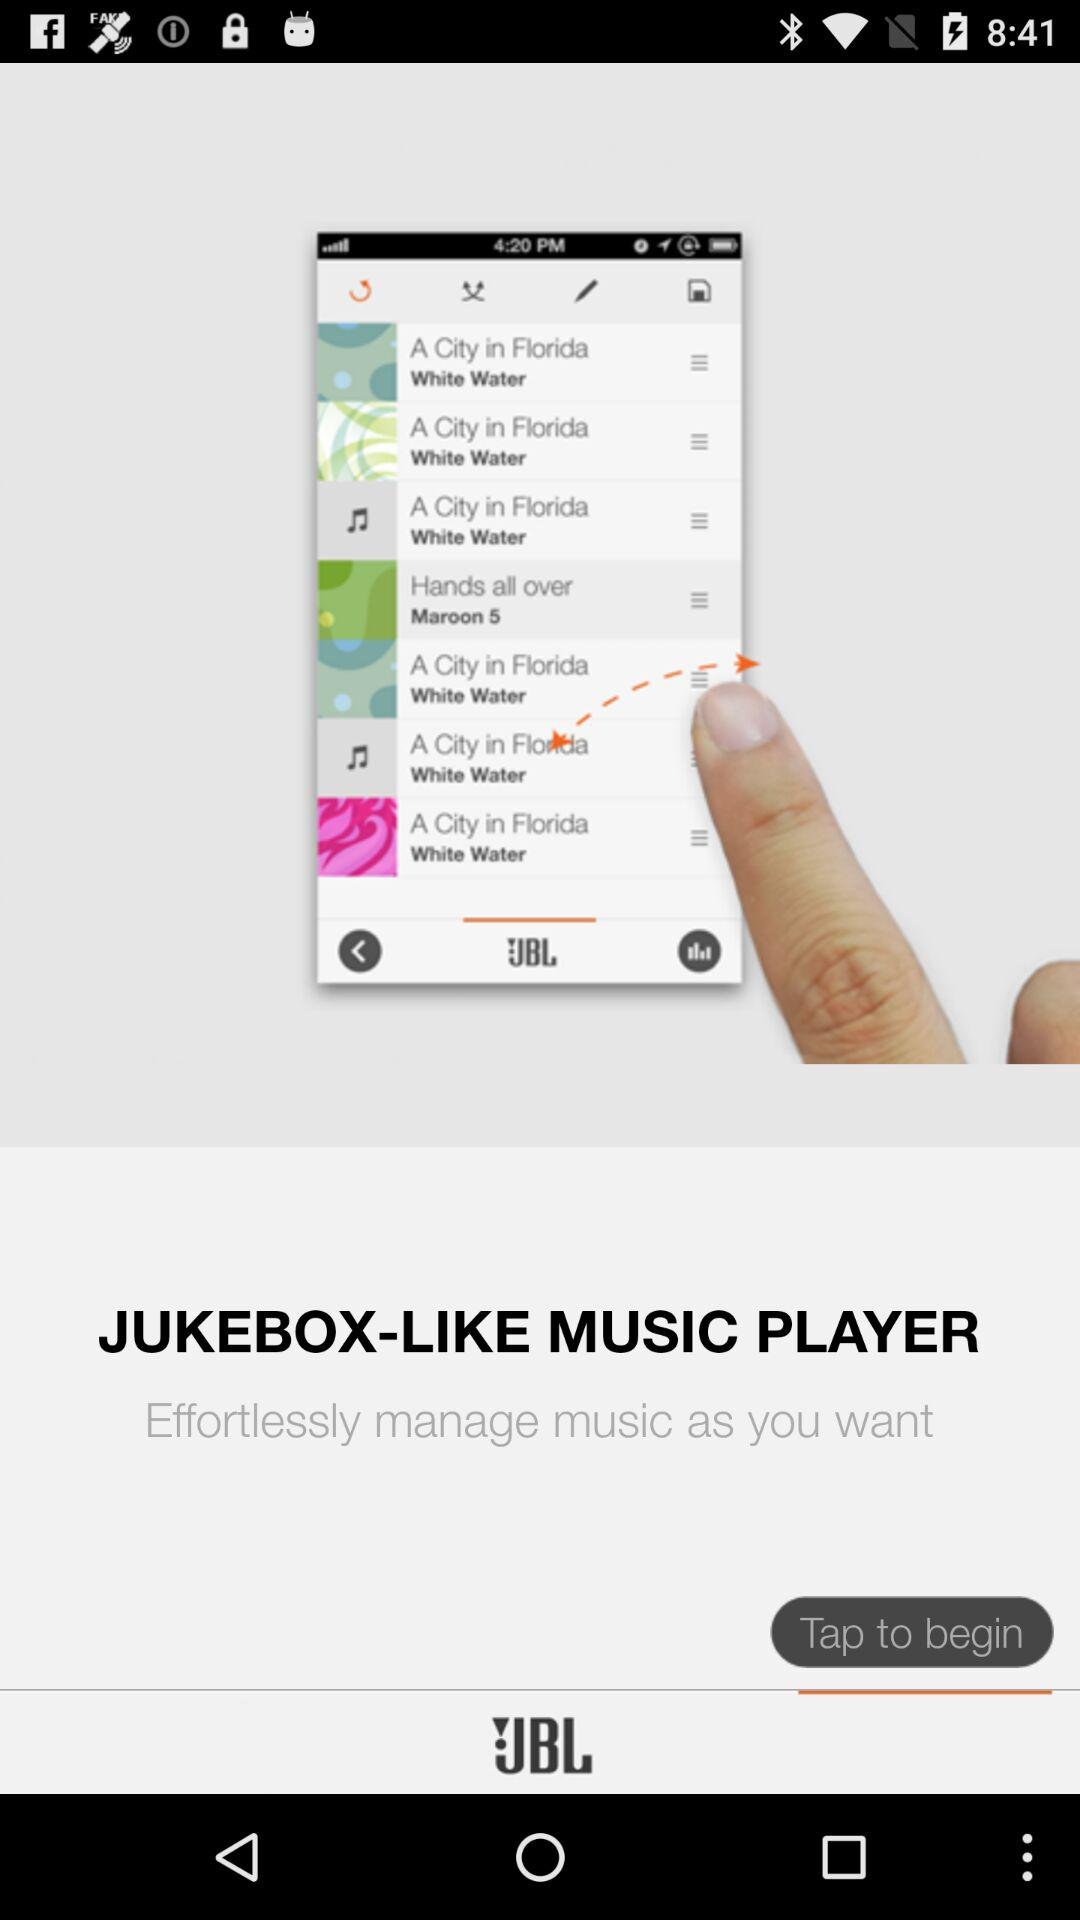What is the duration of "A City in Florida"?
When the provided information is insufficient, respond with <no answer>. <no answer> 